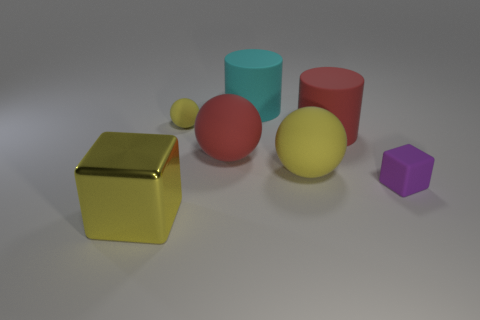Are there more tiny yellow rubber balls left of the yellow metal thing than purple objects that are to the left of the red rubber cylinder?
Keep it short and to the point. No. There is a small thing that is the same color as the metal block; what is it made of?
Offer a very short reply. Rubber. What number of balls are the same color as the large shiny cube?
Your response must be concise. 2. Is the color of the small rubber thing that is in front of the small yellow matte ball the same as the block in front of the purple rubber thing?
Offer a terse response. No. Are there any large metallic things right of the small sphere?
Your response must be concise. No. What is the small yellow thing made of?
Make the answer very short. Rubber. The small purple object to the right of the large cyan rubber thing has what shape?
Provide a short and direct response. Cube. What size is the metal object that is the same color as the tiny matte sphere?
Provide a short and direct response. Large. Is there a yellow metallic block that has the same size as the cyan matte thing?
Provide a succinct answer. Yes. Are the large yellow object to the right of the red ball and the small purple block made of the same material?
Ensure brevity in your answer.  Yes. 